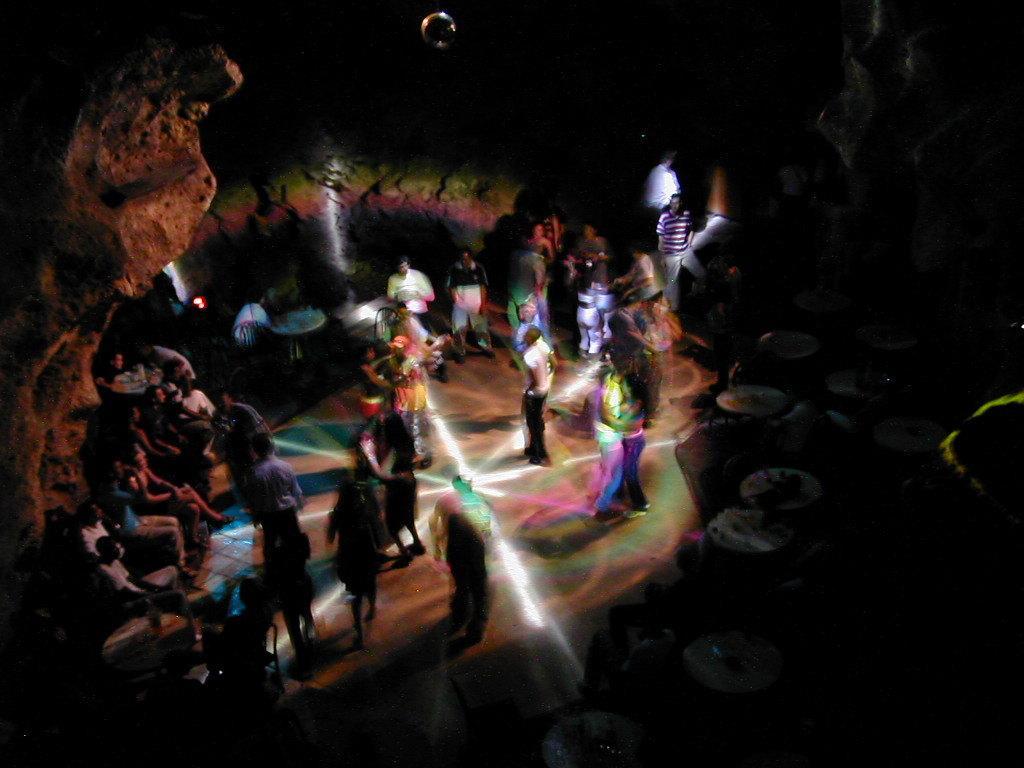Please provide a concise description of this image. In this image I can see people present. There are lights and it looks like a cave. 